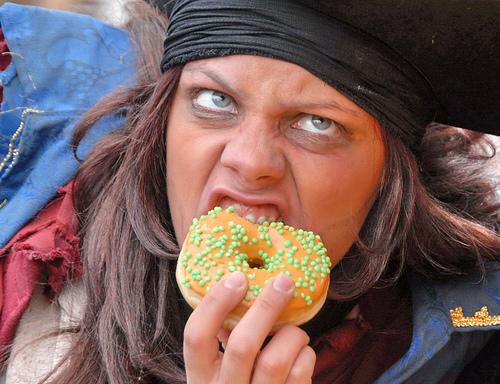What color is the material on her head?
Give a very brief answer. Black. What is covering her donut?
Short answer required. Sprinkles. Is this a wealthy woman?
Be succinct. No. 